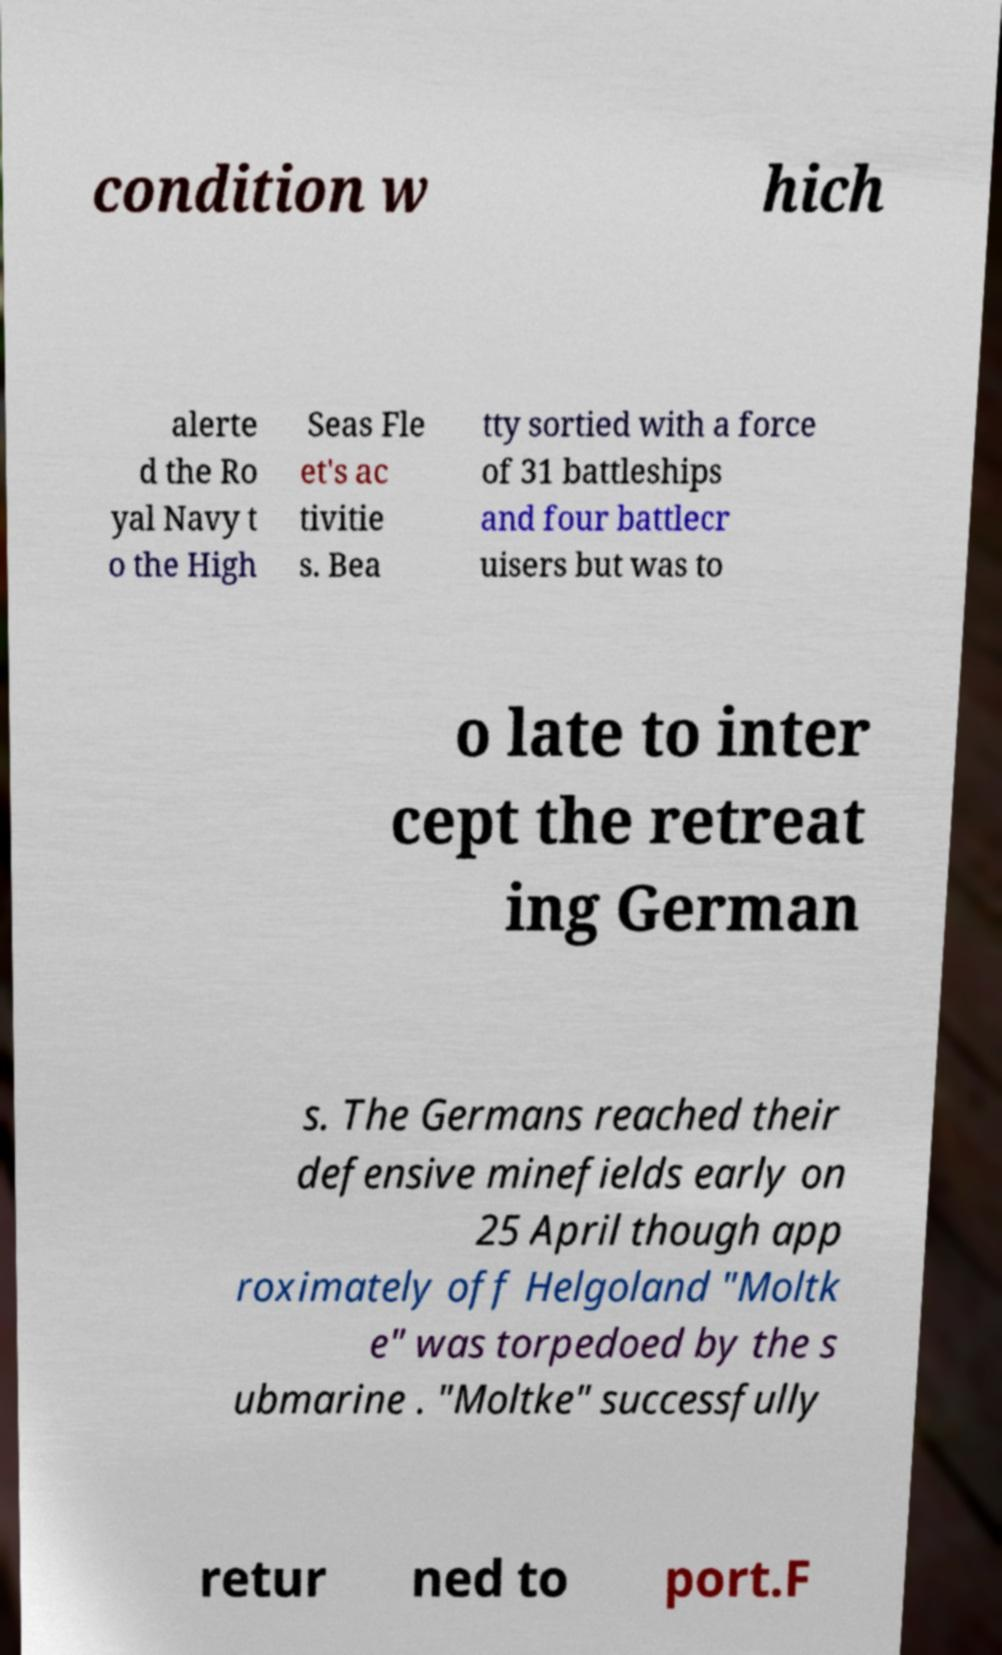There's text embedded in this image that I need extracted. Can you transcribe it verbatim? condition w hich alerte d the Ro yal Navy t o the High Seas Fle et's ac tivitie s. Bea tty sortied with a force of 31 battleships and four battlecr uisers but was to o late to inter cept the retreat ing German s. The Germans reached their defensive minefields early on 25 April though app roximately off Helgoland "Moltk e" was torpedoed by the s ubmarine . "Moltke" successfully retur ned to port.F 